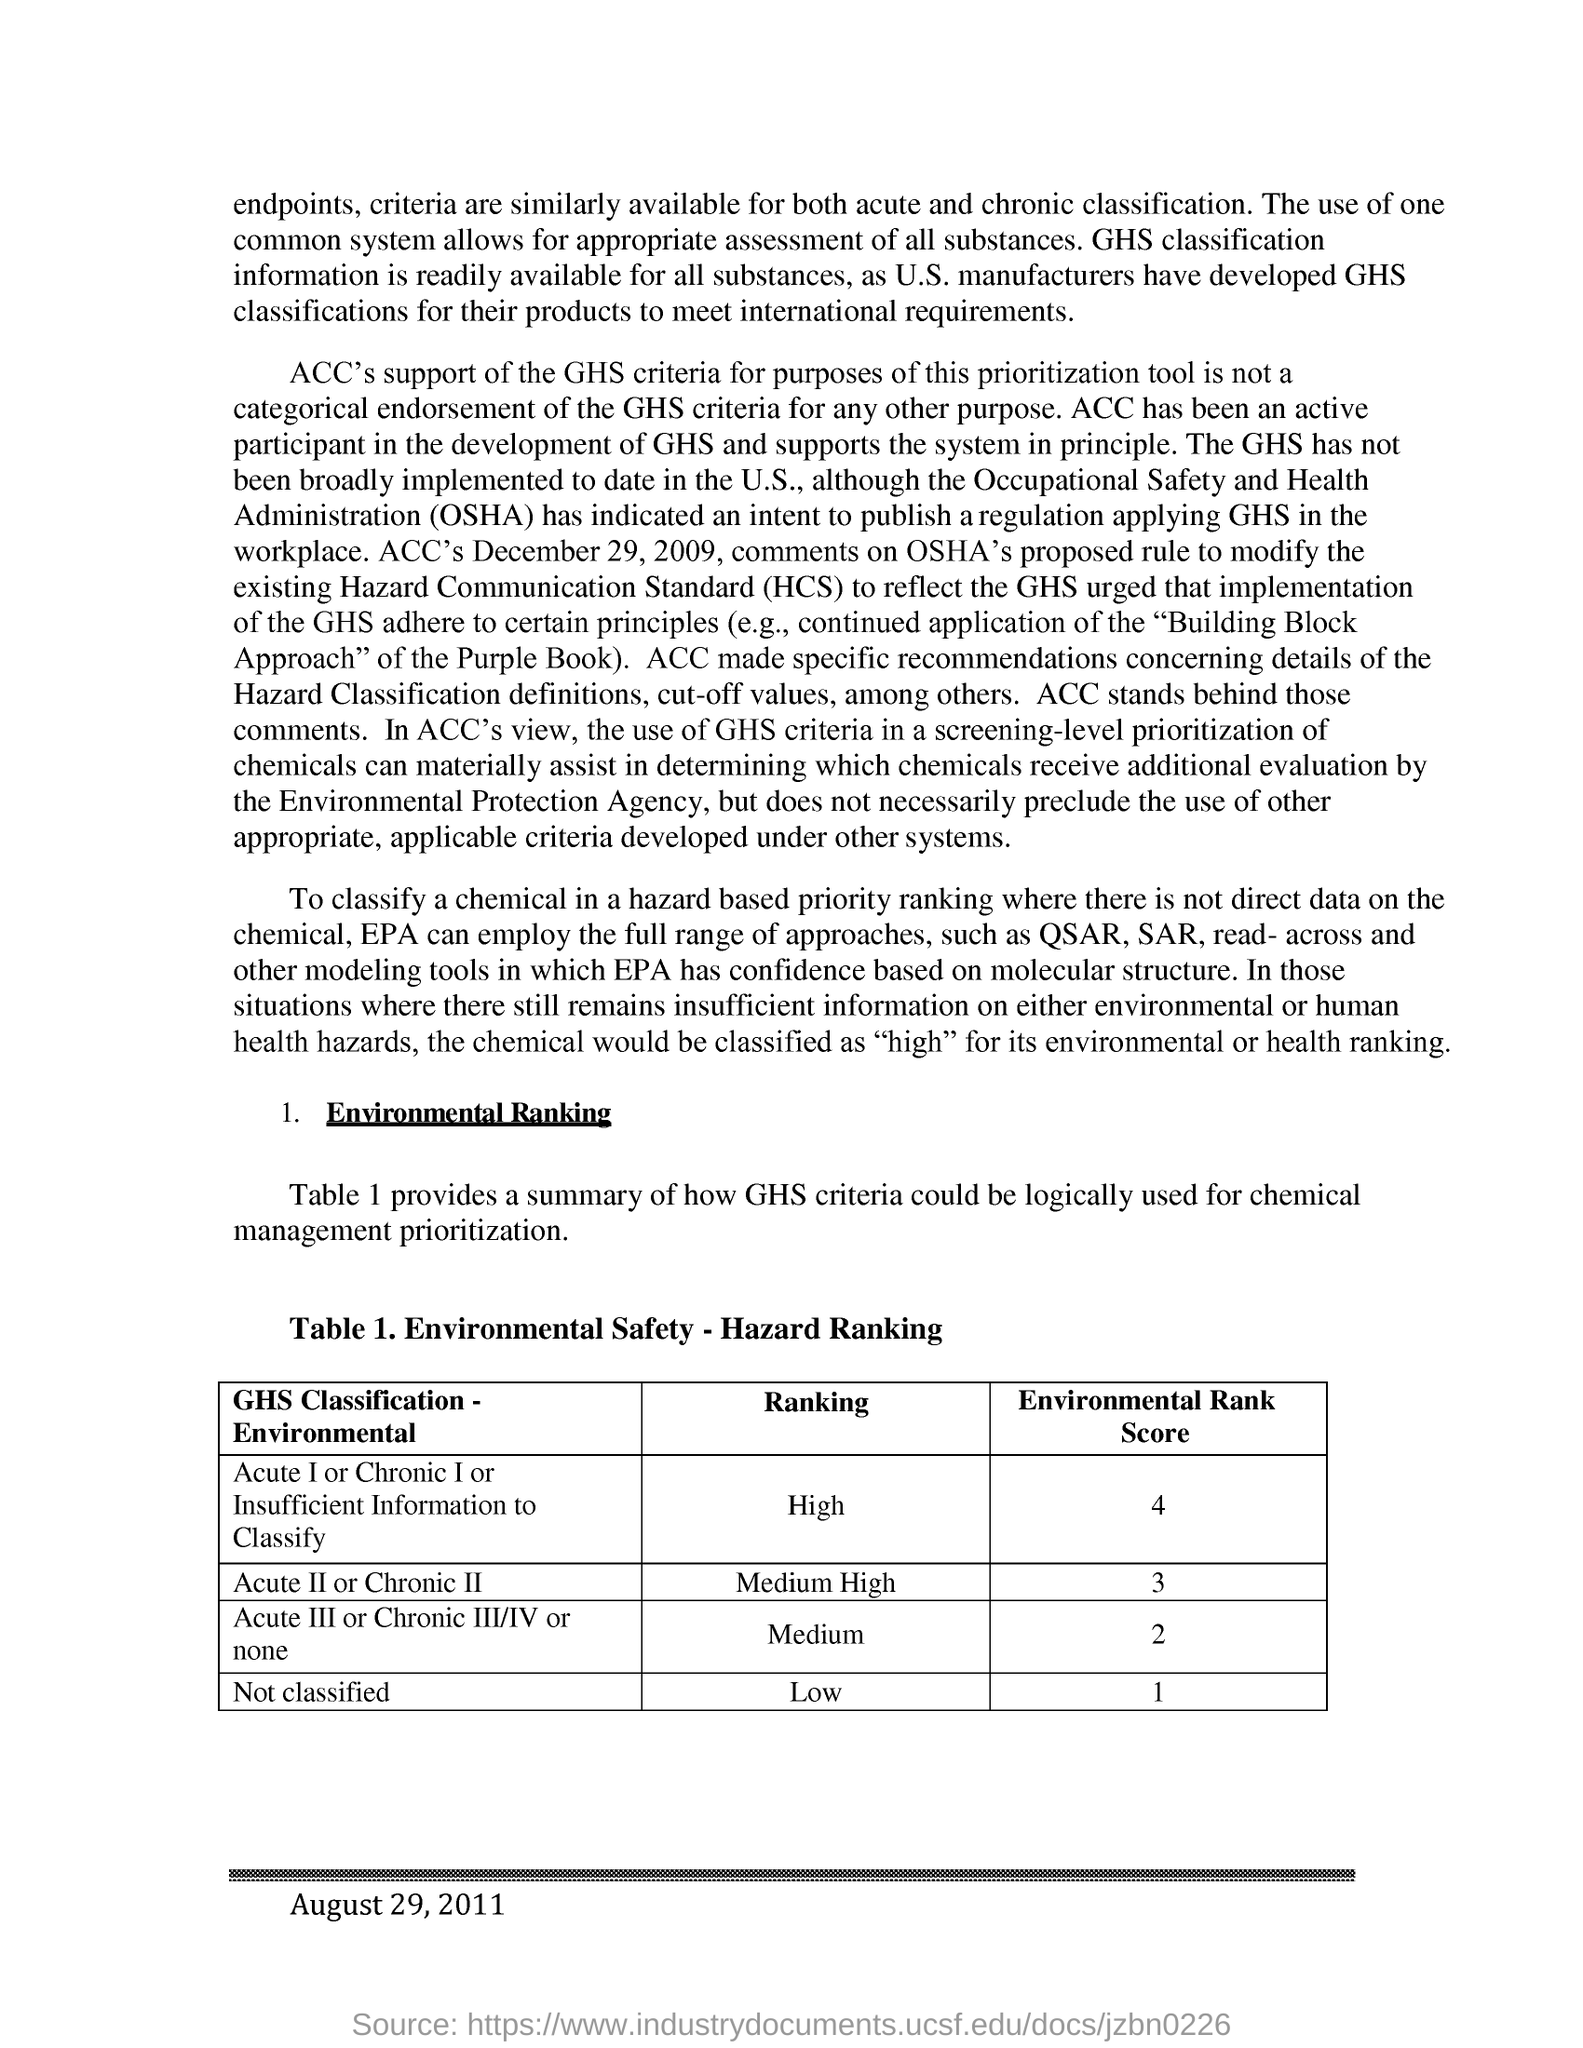What is the title of Table 1.?
Give a very brief answer. Environmenal Safety - Hazard Ranking. What is the fullform of HCS?
Your response must be concise. Hazard Communication Standard. What is the ranking of Acute II or Chronic II - GHS classification?
Offer a terse response. Medium High. What is the abbreviation for Occupational Safety and Health Administration?
Keep it short and to the point. OSHA. What is the environmental rank score of Acute II or Chronic II - GHS Classification?
Your answer should be very brief. 3. 